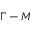Convert formula to latex. <formula><loc_0><loc_0><loc_500><loc_500>\Gamma - M</formula> 